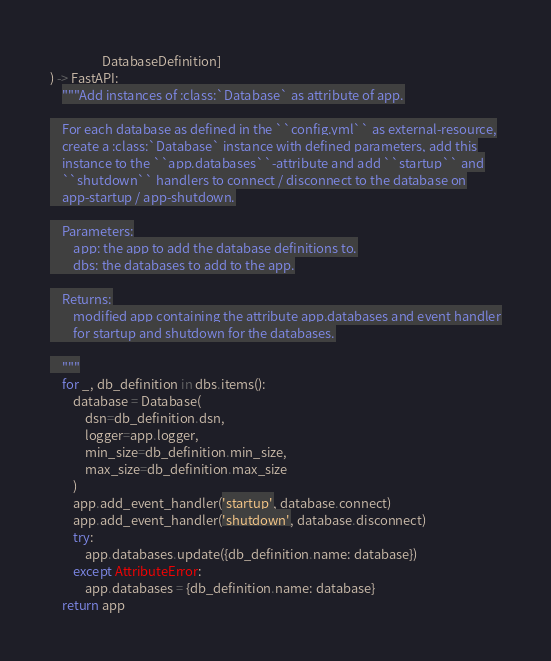Convert code to text. <code><loc_0><loc_0><loc_500><loc_500><_Python_>                  DatabaseDefinition]
) -> FastAPI:
    """Add instances of :class:`Database` as attribute of app.

    For each database as defined in the ``config.yml`` as external-resource,
    create a :class:`Database` instance with defined parameters, add this
    instance to the ``app.databases``-attribute and add ``startup`` and
    ``shutdown`` handlers to connect / disconnect to the database on
    app-startup / app-shutdown.

    Parameters:
        app: the app to add the database definitions to.
        dbs: the databases to add to the app.

    Returns:
        modified app containing the attribute app.databases and event handler
        for startup and shutdown for the databases.

    """
    for _, db_definition in dbs.items():
        database = Database(
            dsn=db_definition.dsn,
            logger=app.logger,
            min_size=db_definition.min_size,
            max_size=db_definition.max_size
        )
        app.add_event_handler('startup', database.connect)
        app.add_event_handler('shutdown', database.disconnect)
        try:
            app.databases.update({db_definition.name: database})
        except AttributeError:
            app.databases = {db_definition.name: database}
    return app
</code> 